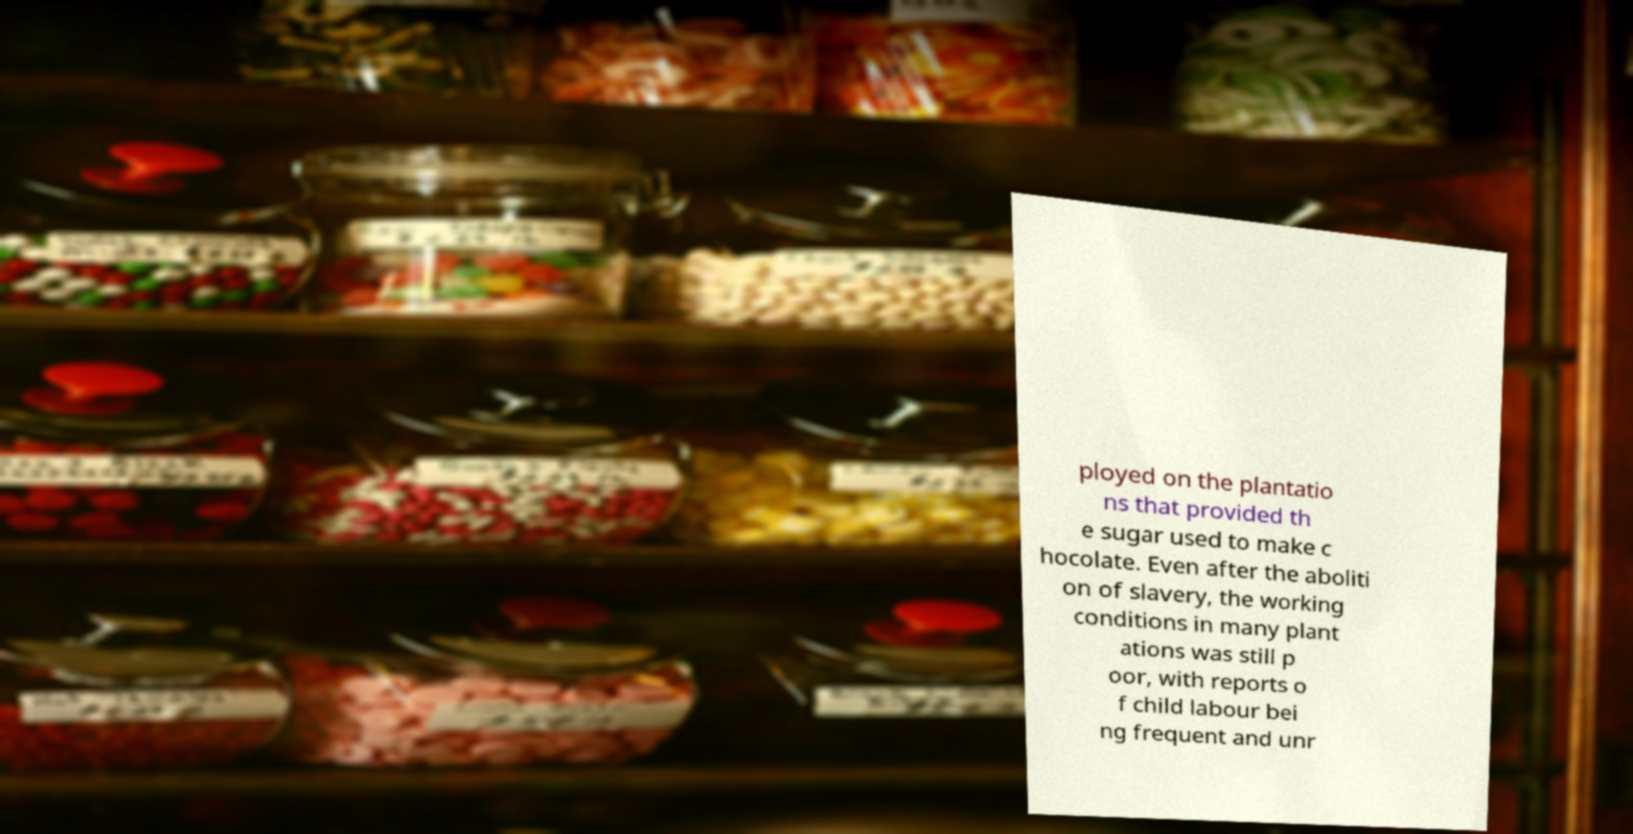Please identify and transcribe the text found in this image. ployed on the plantatio ns that provided th e sugar used to make c hocolate. Even after the aboliti on of slavery, the working conditions in many plant ations was still p oor, with reports o f child labour bei ng frequent and unr 